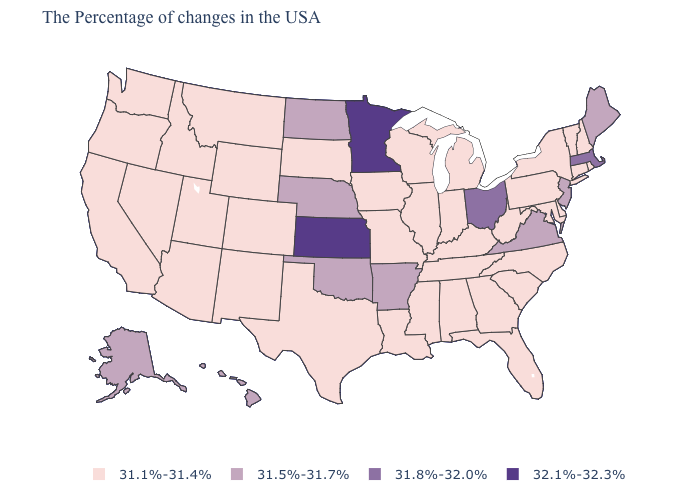Name the states that have a value in the range 31.1%-31.4%?
Keep it brief. Rhode Island, New Hampshire, Vermont, Connecticut, New York, Delaware, Maryland, Pennsylvania, North Carolina, South Carolina, West Virginia, Florida, Georgia, Michigan, Kentucky, Indiana, Alabama, Tennessee, Wisconsin, Illinois, Mississippi, Louisiana, Missouri, Iowa, Texas, South Dakota, Wyoming, Colorado, New Mexico, Utah, Montana, Arizona, Idaho, Nevada, California, Washington, Oregon. What is the highest value in the USA?
Give a very brief answer. 32.1%-32.3%. What is the value of Wisconsin?
Give a very brief answer. 31.1%-31.4%. What is the value of Florida?
Give a very brief answer. 31.1%-31.4%. Does Alabama have the same value as South Dakota?
Concise answer only. Yes. What is the highest value in the USA?
Short answer required. 32.1%-32.3%. Does Michigan have a lower value than Massachusetts?
Quick response, please. Yes. Name the states that have a value in the range 31.1%-31.4%?
Concise answer only. Rhode Island, New Hampshire, Vermont, Connecticut, New York, Delaware, Maryland, Pennsylvania, North Carolina, South Carolina, West Virginia, Florida, Georgia, Michigan, Kentucky, Indiana, Alabama, Tennessee, Wisconsin, Illinois, Mississippi, Louisiana, Missouri, Iowa, Texas, South Dakota, Wyoming, Colorado, New Mexico, Utah, Montana, Arizona, Idaho, Nevada, California, Washington, Oregon. What is the value of Idaho?
Give a very brief answer. 31.1%-31.4%. Name the states that have a value in the range 31.8%-32.0%?
Be succinct. Massachusetts, Ohio. Does California have a higher value than Florida?
Concise answer only. No. What is the value of New Jersey?
Answer briefly. 31.5%-31.7%. What is the value of Arkansas?
Short answer required. 31.5%-31.7%. 